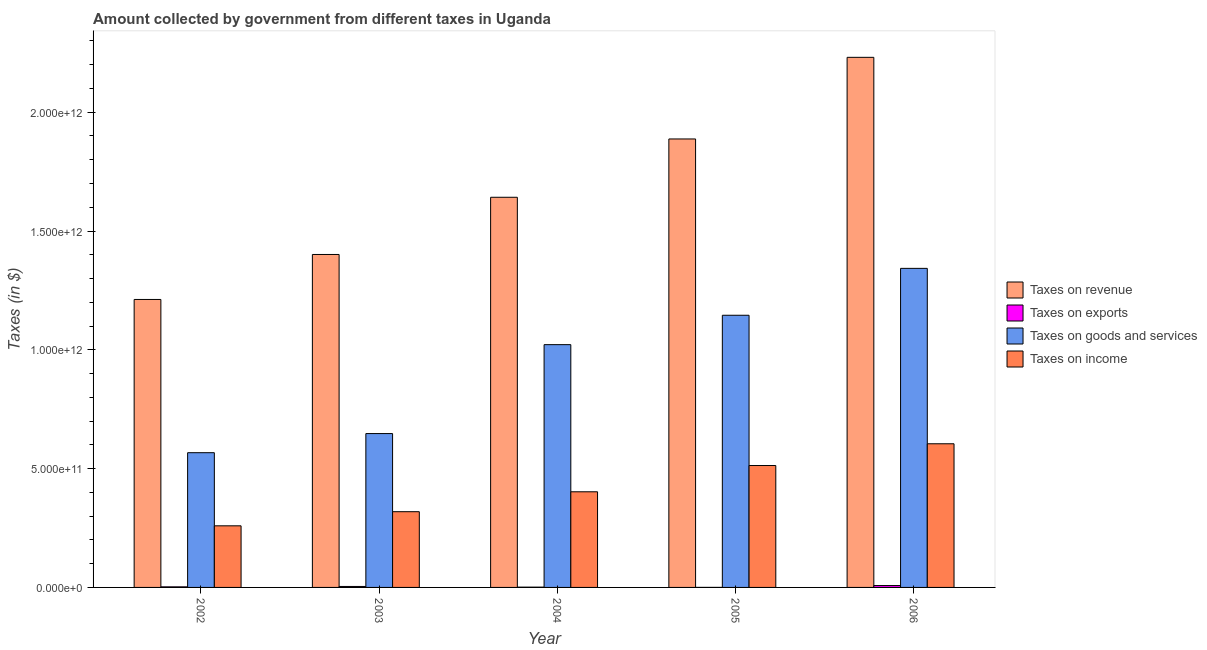How many different coloured bars are there?
Provide a short and direct response. 4. Are the number of bars on each tick of the X-axis equal?
Provide a succinct answer. Yes. How many bars are there on the 3rd tick from the right?
Your answer should be compact. 4. What is the label of the 4th group of bars from the left?
Keep it short and to the point. 2005. What is the amount collected as tax on revenue in 2006?
Ensure brevity in your answer.  2.23e+12. Across all years, what is the maximum amount collected as tax on income?
Make the answer very short. 6.05e+11. Across all years, what is the minimum amount collected as tax on income?
Ensure brevity in your answer.  2.59e+11. In which year was the amount collected as tax on income maximum?
Give a very brief answer. 2006. What is the total amount collected as tax on income in the graph?
Provide a short and direct response. 2.10e+12. What is the difference between the amount collected as tax on revenue in 2005 and that in 2006?
Your answer should be compact. -3.44e+11. What is the difference between the amount collected as tax on income in 2004 and the amount collected as tax on goods in 2002?
Your answer should be compact. 1.43e+11. What is the average amount collected as tax on goods per year?
Make the answer very short. 9.45e+11. In the year 2003, what is the difference between the amount collected as tax on goods and amount collected as tax on exports?
Your answer should be compact. 0. What is the ratio of the amount collected as tax on revenue in 2003 to that in 2004?
Keep it short and to the point. 0.85. What is the difference between the highest and the second highest amount collected as tax on revenue?
Keep it short and to the point. 3.44e+11. What is the difference between the highest and the lowest amount collected as tax on income?
Provide a short and direct response. 3.45e+11. In how many years, is the amount collected as tax on goods greater than the average amount collected as tax on goods taken over all years?
Offer a very short reply. 3. What does the 1st bar from the left in 2002 represents?
Make the answer very short. Taxes on revenue. What does the 3rd bar from the right in 2004 represents?
Your response must be concise. Taxes on exports. How many bars are there?
Your answer should be compact. 20. Are all the bars in the graph horizontal?
Your answer should be very brief. No. How many years are there in the graph?
Keep it short and to the point. 5. What is the difference between two consecutive major ticks on the Y-axis?
Keep it short and to the point. 5.00e+11. Are the values on the major ticks of Y-axis written in scientific E-notation?
Provide a short and direct response. Yes. Does the graph contain any zero values?
Offer a very short reply. No. How many legend labels are there?
Keep it short and to the point. 4. How are the legend labels stacked?
Provide a short and direct response. Vertical. What is the title of the graph?
Provide a succinct answer. Amount collected by government from different taxes in Uganda. Does "Australia" appear as one of the legend labels in the graph?
Your response must be concise. No. What is the label or title of the Y-axis?
Provide a succinct answer. Taxes (in $). What is the Taxes (in $) in Taxes on revenue in 2002?
Provide a succinct answer. 1.21e+12. What is the Taxes (in $) in Taxes on exports in 2002?
Provide a short and direct response. 2.43e+09. What is the Taxes (in $) in Taxes on goods and services in 2002?
Keep it short and to the point. 5.67e+11. What is the Taxes (in $) of Taxes on income in 2002?
Keep it short and to the point. 2.59e+11. What is the Taxes (in $) of Taxes on revenue in 2003?
Make the answer very short. 1.40e+12. What is the Taxes (in $) of Taxes on exports in 2003?
Provide a succinct answer. 4.07e+09. What is the Taxes (in $) in Taxes on goods and services in 2003?
Make the answer very short. 6.48e+11. What is the Taxes (in $) in Taxes on income in 2003?
Keep it short and to the point. 3.19e+11. What is the Taxes (in $) of Taxes on revenue in 2004?
Your response must be concise. 1.64e+12. What is the Taxes (in $) in Taxes on exports in 2004?
Provide a succinct answer. 1.14e+09. What is the Taxes (in $) of Taxes on goods and services in 2004?
Provide a short and direct response. 1.02e+12. What is the Taxes (in $) of Taxes on income in 2004?
Ensure brevity in your answer.  4.02e+11. What is the Taxes (in $) of Taxes on revenue in 2005?
Offer a terse response. 1.89e+12. What is the Taxes (in $) of Taxes on exports in 2005?
Your response must be concise. 1.22e+08. What is the Taxes (in $) of Taxes on goods and services in 2005?
Give a very brief answer. 1.15e+12. What is the Taxes (in $) of Taxes on income in 2005?
Offer a very short reply. 5.13e+11. What is the Taxes (in $) of Taxes on revenue in 2006?
Offer a terse response. 2.23e+12. What is the Taxes (in $) in Taxes on exports in 2006?
Give a very brief answer. 7.93e+09. What is the Taxes (in $) in Taxes on goods and services in 2006?
Provide a short and direct response. 1.34e+12. What is the Taxes (in $) of Taxes on income in 2006?
Ensure brevity in your answer.  6.05e+11. Across all years, what is the maximum Taxes (in $) of Taxes on revenue?
Your answer should be compact. 2.23e+12. Across all years, what is the maximum Taxes (in $) of Taxes on exports?
Offer a very short reply. 7.93e+09. Across all years, what is the maximum Taxes (in $) of Taxes on goods and services?
Give a very brief answer. 1.34e+12. Across all years, what is the maximum Taxes (in $) in Taxes on income?
Your response must be concise. 6.05e+11. Across all years, what is the minimum Taxes (in $) in Taxes on revenue?
Offer a very short reply. 1.21e+12. Across all years, what is the minimum Taxes (in $) of Taxes on exports?
Your response must be concise. 1.22e+08. Across all years, what is the minimum Taxes (in $) of Taxes on goods and services?
Your response must be concise. 5.67e+11. Across all years, what is the minimum Taxes (in $) of Taxes on income?
Keep it short and to the point. 2.59e+11. What is the total Taxes (in $) in Taxes on revenue in the graph?
Your response must be concise. 8.37e+12. What is the total Taxes (in $) of Taxes on exports in the graph?
Give a very brief answer. 1.57e+1. What is the total Taxes (in $) of Taxes on goods and services in the graph?
Keep it short and to the point. 4.72e+12. What is the total Taxes (in $) of Taxes on income in the graph?
Provide a succinct answer. 2.10e+12. What is the difference between the Taxes (in $) of Taxes on revenue in 2002 and that in 2003?
Your answer should be very brief. -1.89e+11. What is the difference between the Taxes (in $) of Taxes on exports in 2002 and that in 2003?
Your answer should be very brief. -1.64e+09. What is the difference between the Taxes (in $) of Taxes on goods and services in 2002 and that in 2003?
Offer a terse response. -8.05e+1. What is the difference between the Taxes (in $) of Taxes on income in 2002 and that in 2003?
Keep it short and to the point. -5.94e+1. What is the difference between the Taxes (in $) in Taxes on revenue in 2002 and that in 2004?
Offer a very short reply. -4.30e+11. What is the difference between the Taxes (in $) of Taxes on exports in 2002 and that in 2004?
Provide a short and direct response. 1.30e+09. What is the difference between the Taxes (in $) of Taxes on goods and services in 2002 and that in 2004?
Give a very brief answer. -4.55e+11. What is the difference between the Taxes (in $) of Taxes on income in 2002 and that in 2004?
Offer a very short reply. -1.43e+11. What is the difference between the Taxes (in $) of Taxes on revenue in 2002 and that in 2005?
Ensure brevity in your answer.  -6.75e+11. What is the difference between the Taxes (in $) of Taxes on exports in 2002 and that in 2005?
Make the answer very short. 2.31e+09. What is the difference between the Taxes (in $) in Taxes on goods and services in 2002 and that in 2005?
Your answer should be compact. -5.78e+11. What is the difference between the Taxes (in $) in Taxes on income in 2002 and that in 2005?
Ensure brevity in your answer.  -2.54e+11. What is the difference between the Taxes (in $) of Taxes on revenue in 2002 and that in 2006?
Your answer should be very brief. -1.02e+12. What is the difference between the Taxes (in $) of Taxes on exports in 2002 and that in 2006?
Offer a terse response. -5.50e+09. What is the difference between the Taxes (in $) of Taxes on goods and services in 2002 and that in 2006?
Your response must be concise. -7.76e+11. What is the difference between the Taxes (in $) in Taxes on income in 2002 and that in 2006?
Provide a succinct answer. -3.45e+11. What is the difference between the Taxes (in $) in Taxes on revenue in 2003 and that in 2004?
Offer a very short reply. -2.41e+11. What is the difference between the Taxes (in $) of Taxes on exports in 2003 and that in 2004?
Give a very brief answer. 2.94e+09. What is the difference between the Taxes (in $) in Taxes on goods and services in 2003 and that in 2004?
Give a very brief answer. -3.74e+11. What is the difference between the Taxes (in $) in Taxes on income in 2003 and that in 2004?
Offer a terse response. -8.38e+1. What is the difference between the Taxes (in $) in Taxes on revenue in 2003 and that in 2005?
Give a very brief answer. -4.86e+11. What is the difference between the Taxes (in $) in Taxes on exports in 2003 and that in 2005?
Provide a succinct answer. 3.95e+09. What is the difference between the Taxes (in $) in Taxes on goods and services in 2003 and that in 2005?
Give a very brief answer. -4.98e+11. What is the difference between the Taxes (in $) in Taxes on income in 2003 and that in 2005?
Your response must be concise. -1.94e+11. What is the difference between the Taxes (in $) of Taxes on revenue in 2003 and that in 2006?
Provide a short and direct response. -8.30e+11. What is the difference between the Taxes (in $) of Taxes on exports in 2003 and that in 2006?
Make the answer very short. -3.86e+09. What is the difference between the Taxes (in $) in Taxes on goods and services in 2003 and that in 2006?
Give a very brief answer. -6.95e+11. What is the difference between the Taxes (in $) in Taxes on income in 2003 and that in 2006?
Ensure brevity in your answer.  -2.86e+11. What is the difference between the Taxes (in $) of Taxes on revenue in 2004 and that in 2005?
Keep it short and to the point. -2.45e+11. What is the difference between the Taxes (in $) in Taxes on exports in 2004 and that in 2005?
Your answer should be very brief. 1.01e+09. What is the difference between the Taxes (in $) in Taxes on goods and services in 2004 and that in 2005?
Offer a terse response. -1.24e+11. What is the difference between the Taxes (in $) in Taxes on income in 2004 and that in 2005?
Your answer should be compact. -1.11e+11. What is the difference between the Taxes (in $) of Taxes on revenue in 2004 and that in 2006?
Provide a short and direct response. -5.89e+11. What is the difference between the Taxes (in $) in Taxes on exports in 2004 and that in 2006?
Make the answer very short. -6.79e+09. What is the difference between the Taxes (in $) of Taxes on goods and services in 2004 and that in 2006?
Your answer should be very brief. -3.21e+11. What is the difference between the Taxes (in $) in Taxes on income in 2004 and that in 2006?
Your answer should be very brief. -2.02e+11. What is the difference between the Taxes (in $) in Taxes on revenue in 2005 and that in 2006?
Give a very brief answer. -3.44e+11. What is the difference between the Taxes (in $) of Taxes on exports in 2005 and that in 2006?
Offer a very short reply. -7.81e+09. What is the difference between the Taxes (in $) of Taxes on goods and services in 2005 and that in 2006?
Offer a very short reply. -1.97e+11. What is the difference between the Taxes (in $) of Taxes on income in 2005 and that in 2006?
Provide a succinct answer. -9.16e+1. What is the difference between the Taxes (in $) of Taxes on revenue in 2002 and the Taxes (in $) of Taxes on exports in 2003?
Offer a terse response. 1.21e+12. What is the difference between the Taxes (in $) of Taxes on revenue in 2002 and the Taxes (in $) of Taxes on goods and services in 2003?
Keep it short and to the point. 5.64e+11. What is the difference between the Taxes (in $) in Taxes on revenue in 2002 and the Taxes (in $) in Taxes on income in 2003?
Offer a terse response. 8.93e+11. What is the difference between the Taxes (in $) in Taxes on exports in 2002 and the Taxes (in $) in Taxes on goods and services in 2003?
Ensure brevity in your answer.  -6.45e+11. What is the difference between the Taxes (in $) in Taxes on exports in 2002 and the Taxes (in $) in Taxes on income in 2003?
Offer a terse response. -3.16e+11. What is the difference between the Taxes (in $) in Taxes on goods and services in 2002 and the Taxes (in $) in Taxes on income in 2003?
Provide a short and direct response. 2.48e+11. What is the difference between the Taxes (in $) in Taxes on revenue in 2002 and the Taxes (in $) in Taxes on exports in 2004?
Ensure brevity in your answer.  1.21e+12. What is the difference between the Taxes (in $) in Taxes on revenue in 2002 and the Taxes (in $) in Taxes on goods and services in 2004?
Make the answer very short. 1.90e+11. What is the difference between the Taxes (in $) of Taxes on revenue in 2002 and the Taxes (in $) of Taxes on income in 2004?
Make the answer very short. 8.09e+11. What is the difference between the Taxes (in $) of Taxes on exports in 2002 and the Taxes (in $) of Taxes on goods and services in 2004?
Keep it short and to the point. -1.02e+12. What is the difference between the Taxes (in $) of Taxes on exports in 2002 and the Taxes (in $) of Taxes on income in 2004?
Make the answer very short. -4.00e+11. What is the difference between the Taxes (in $) of Taxes on goods and services in 2002 and the Taxes (in $) of Taxes on income in 2004?
Keep it short and to the point. 1.65e+11. What is the difference between the Taxes (in $) in Taxes on revenue in 2002 and the Taxes (in $) in Taxes on exports in 2005?
Give a very brief answer. 1.21e+12. What is the difference between the Taxes (in $) of Taxes on revenue in 2002 and the Taxes (in $) of Taxes on goods and services in 2005?
Your response must be concise. 6.65e+1. What is the difference between the Taxes (in $) of Taxes on revenue in 2002 and the Taxes (in $) of Taxes on income in 2005?
Keep it short and to the point. 6.99e+11. What is the difference between the Taxes (in $) in Taxes on exports in 2002 and the Taxes (in $) in Taxes on goods and services in 2005?
Keep it short and to the point. -1.14e+12. What is the difference between the Taxes (in $) of Taxes on exports in 2002 and the Taxes (in $) of Taxes on income in 2005?
Your answer should be compact. -5.11e+11. What is the difference between the Taxes (in $) of Taxes on goods and services in 2002 and the Taxes (in $) of Taxes on income in 2005?
Your response must be concise. 5.40e+1. What is the difference between the Taxes (in $) of Taxes on revenue in 2002 and the Taxes (in $) of Taxes on exports in 2006?
Offer a very short reply. 1.20e+12. What is the difference between the Taxes (in $) in Taxes on revenue in 2002 and the Taxes (in $) in Taxes on goods and services in 2006?
Your answer should be compact. -1.31e+11. What is the difference between the Taxes (in $) in Taxes on revenue in 2002 and the Taxes (in $) in Taxes on income in 2006?
Your response must be concise. 6.07e+11. What is the difference between the Taxes (in $) in Taxes on exports in 2002 and the Taxes (in $) in Taxes on goods and services in 2006?
Make the answer very short. -1.34e+12. What is the difference between the Taxes (in $) of Taxes on exports in 2002 and the Taxes (in $) of Taxes on income in 2006?
Offer a very short reply. -6.02e+11. What is the difference between the Taxes (in $) of Taxes on goods and services in 2002 and the Taxes (in $) of Taxes on income in 2006?
Offer a very short reply. -3.76e+1. What is the difference between the Taxes (in $) of Taxes on revenue in 2003 and the Taxes (in $) of Taxes on exports in 2004?
Your answer should be compact. 1.40e+12. What is the difference between the Taxes (in $) in Taxes on revenue in 2003 and the Taxes (in $) in Taxes on goods and services in 2004?
Provide a short and direct response. 3.80e+11. What is the difference between the Taxes (in $) of Taxes on revenue in 2003 and the Taxes (in $) of Taxes on income in 2004?
Offer a terse response. 9.99e+11. What is the difference between the Taxes (in $) in Taxes on exports in 2003 and the Taxes (in $) in Taxes on goods and services in 2004?
Your response must be concise. -1.02e+12. What is the difference between the Taxes (in $) in Taxes on exports in 2003 and the Taxes (in $) in Taxes on income in 2004?
Give a very brief answer. -3.98e+11. What is the difference between the Taxes (in $) in Taxes on goods and services in 2003 and the Taxes (in $) in Taxes on income in 2004?
Make the answer very short. 2.45e+11. What is the difference between the Taxes (in $) in Taxes on revenue in 2003 and the Taxes (in $) in Taxes on exports in 2005?
Offer a very short reply. 1.40e+12. What is the difference between the Taxes (in $) of Taxes on revenue in 2003 and the Taxes (in $) of Taxes on goods and services in 2005?
Give a very brief answer. 2.56e+11. What is the difference between the Taxes (in $) in Taxes on revenue in 2003 and the Taxes (in $) in Taxes on income in 2005?
Keep it short and to the point. 8.88e+11. What is the difference between the Taxes (in $) in Taxes on exports in 2003 and the Taxes (in $) in Taxes on goods and services in 2005?
Offer a terse response. -1.14e+12. What is the difference between the Taxes (in $) of Taxes on exports in 2003 and the Taxes (in $) of Taxes on income in 2005?
Provide a short and direct response. -5.09e+11. What is the difference between the Taxes (in $) of Taxes on goods and services in 2003 and the Taxes (in $) of Taxes on income in 2005?
Ensure brevity in your answer.  1.34e+11. What is the difference between the Taxes (in $) of Taxes on revenue in 2003 and the Taxes (in $) of Taxes on exports in 2006?
Your answer should be very brief. 1.39e+12. What is the difference between the Taxes (in $) of Taxes on revenue in 2003 and the Taxes (in $) of Taxes on goods and services in 2006?
Offer a terse response. 5.84e+1. What is the difference between the Taxes (in $) of Taxes on revenue in 2003 and the Taxes (in $) of Taxes on income in 2006?
Your answer should be compact. 7.97e+11. What is the difference between the Taxes (in $) of Taxes on exports in 2003 and the Taxes (in $) of Taxes on goods and services in 2006?
Provide a succinct answer. -1.34e+12. What is the difference between the Taxes (in $) in Taxes on exports in 2003 and the Taxes (in $) in Taxes on income in 2006?
Give a very brief answer. -6.01e+11. What is the difference between the Taxes (in $) of Taxes on goods and services in 2003 and the Taxes (in $) of Taxes on income in 2006?
Provide a succinct answer. 4.29e+1. What is the difference between the Taxes (in $) in Taxes on revenue in 2004 and the Taxes (in $) in Taxes on exports in 2005?
Provide a short and direct response. 1.64e+12. What is the difference between the Taxes (in $) of Taxes on revenue in 2004 and the Taxes (in $) of Taxes on goods and services in 2005?
Offer a terse response. 4.97e+11. What is the difference between the Taxes (in $) of Taxes on revenue in 2004 and the Taxes (in $) of Taxes on income in 2005?
Your answer should be very brief. 1.13e+12. What is the difference between the Taxes (in $) in Taxes on exports in 2004 and the Taxes (in $) in Taxes on goods and services in 2005?
Give a very brief answer. -1.14e+12. What is the difference between the Taxes (in $) of Taxes on exports in 2004 and the Taxes (in $) of Taxes on income in 2005?
Ensure brevity in your answer.  -5.12e+11. What is the difference between the Taxes (in $) of Taxes on goods and services in 2004 and the Taxes (in $) of Taxes on income in 2005?
Offer a terse response. 5.09e+11. What is the difference between the Taxes (in $) of Taxes on revenue in 2004 and the Taxes (in $) of Taxes on exports in 2006?
Make the answer very short. 1.63e+12. What is the difference between the Taxes (in $) in Taxes on revenue in 2004 and the Taxes (in $) in Taxes on goods and services in 2006?
Your response must be concise. 2.99e+11. What is the difference between the Taxes (in $) in Taxes on revenue in 2004 and the Taxes (in $) in Taxes on income in 2006?
Your response must be concise. 1.04e+12. What is the difference between the Taxes (in $) of Taxes on exports in 2004 and the Taxes (in $) of Taxes on goods and services in 2006?
Keep it short and to the point. -1.34e+12. What is the difference between the Taxes (in $) in Taxes on exports in 2004 and the Taxes (in $) in Taxes on income in 2006?
Ensure brevity in your answer.  -6.03e+11. What is the difference between the Taxes (in $) of Taxes on goods and services in 2004 and the Taxes (in $) of Taxes on income in 2006?
Make the answer very short. 4.17e+11. What is the difference between the Taxes (in $) of Taxes on revenue in 2005 and the Taxes (in $) of Taxes on exports in 2006?
Your response must be concise. 1.88e+12. What is the difference between the Taxes (in $) in Taxes on revenue in 2005 and the Taxes (in $) in Taxes on goods and services in 2006?
Keep it short and to the point. 5.45e+11. What is the difference between the Taxes (in $) of Taxes on revenue in 2005 and the Taxes (in $) of Taxes on income in 2006?
Make the answer very short. 1.28e+12. What is the difference between the Taxes (in $) in Taxes on exports in 2005 and the Taxes (in $) in Taxes on goods and services in 2006?
Provide a succinct answer. -1.34e+12. What is the difference between the Taxes (in $) of Taxes on exports in 2005 and the Taxes (in $) of Taxes on income in 2006?
Offer a terse response. -6.04e+11. What is the difference between the Taxes (in $) of Taxes on goods and services in 2005 and the Taxes (in $) of Taxes on income in 2006?
Your answer should be compact. 5.41e+11. What is the average Taxes (in $) in Taxes on revenue per year?
Give a very brief answer. 1.67e+12. What is the average Taxes (in $) in Taxes on exports per year?
Offer a very short reply. 3.14e+09. What is the average Taxes (in $) of Taxes on goods and services per year?
Your response must be concise. 9.45e+11. What is the average Taxes (in $) of Taxes on income per year?
Offer a very short reply. 4.20e+11. In the year 2002, what is the difference between the Taxes (in $) of Taxes on revenue and Taxes (in $) of Taxes on exports?
Keep it short and to the point. 1.21e+12. In the year 2002, what is the difference between the Taxes (in $) of Taxes on revenue and Taxes (in $) of Taxes on goods and services?
Offer a very short reply. 6.45e+11. In the year 2002, what is the difference between the Taxes (in $) in Taxes on revenue and Taxes (in $) in Taxes on income?
Keep it short and to the point. 9.53e+11. In the year 2002, what is the difference between the Taxes (in $) of Taxes on exports and Taxes (in $) of Taxes on goods and services?
Make the answer very short. -5.65e+11. In the year 2002, what is the difference between the Taxes (in $) in Taxes on exports and Taxes (in $) in Taxes on income?
Make the answer very short. -2.57e+11. In the year 2002, what is the difference between the Taxes (in $) in Taxes on goods and services and Taxes (in $) in Taxes on income?
Your answer should be very brief. 3.08e+11. In the year 2003, what is the difference between the Taxes (in $) of Taxes on revenue and Taxes (in $) of Taxes on exports?
Your answer should be compact. 1.40e+12. In the year 2003, what is the difference between the Taxes (in $) in Taxes on revenue and Taxes (in $) in Taxes on goods and services?
Offer a very short reply. 7.54e+11. In the year 2003, what is the difference between the Taxes (in $) of Taxes on revenue and Taxes (in $) of Taxes on income?
Your response must be concise. 1.08e+12. In the year 2003, what is the difference between the Taxes (in $) in Taxes on exports and Taxes (in $) in Taxes on goods and services?
Offer a terse response. -6.43e+11. In the year 2003, what is the difference between the Taxes (in $) of Taxes on exports and Taxes (in $) of Taxes on income?
Your answer should be very brief. -3.15e+11. In the year 2003, what is the difference between the Taxes (in $) in Taxes on goods and services and Taxes (in $) in Taxes on income?
Keep it short and to the point. 3.29e+11. In the year 2004, what is the difference between the Taxes (in $) of Taxes on revenue and Taxes (in $) of Taxes on exports?
Your response must be concise. 1.64e+12. In the year 2004, what is the difference between the Taxes (in $) of Taxes on revenue and Taxes (in $) of Taxes on goods and services?
Your answer should be compact. 6.20e+11. In the year 2004, what is the difference between the Taxes (in $) in Taxes on revenue and Taxes (in $) in Taxes on income?
Your answer should be very brief. 1.24e+12. In the year 2004, what is the difference between the Taxes (in $) in Taxes on exports and Taxes (in $) in Taxes on goods and services?
Your response must be concise. -1.02e+12. In the year 2004, what is the difference between the Taxes (in $) in Taxes on exports and Taxes (in $) in Taxes on income?
Ensure brevity in your answer.  -4.01e+11. In the year 2004, what is the difference between the Taxes (in $) in Taxes on goods and services and Taxes (in $) in Taxes on income?
Provide a succinct answer. 6.19e+11. In the year 2005, what is the difference between the Taxes (in $) in Taxes on revenue and Taxes (in $) in Taxes on exports?
Provide a short and direct response. 1.89e+12. In the year 2005, what is the difference between the Taxes (in $) in Taxes on revenue and Taxes (in $) in Taxes on goods and services?
Your answer should be compact. 7.42e+11. In the year 2005, what is the difference between the Taxes (in $) of Taxes on revenue and Taxes (in $) of Taxes on income?
Your response must be concise. 1.37e+12. In the year 2005, what is the difference between the Taxes (in $) in Taxes on exports and Taxes (in $) in Taxes on goods and services?
Offer a very short reply. -1.15e+12. In the year 2005, what is the difference between the Taxes (in $) of Taxes on exports and Taxes (in $) of Taxes on income?
Provide a short and direct response. -5.13e+11. In the year 2005, what is the difference between the Taxes (in $) of Taxes on goods and services and Taxes (in $) of Taxes on income?
Provide a succinct answer. 6.32e+11. In the year 2006, what is the difference between the Taxes (in $) in Taxes on revenue and Taxes (in $) in Taxes on exports?
Make the answer very short. 2.22e+12. In the year 2006, what is the difference between the Taxes (in $) in Taxes on revenue and Taxes (in $) in Taxes on goods and services?
Keep it short and to the point. 8.88e+11. In the year 2006, what is the difference between the Taxes (in $) in Taxes on revenue and Taxes (in $) in Taxes on income?
Ensure brevity in your answer.  1.63e+12. In the year 2006, what is the difference between the Taxes (in $) in Taxes on exports and Taxes (in $) in Taxes on goods and services?
Your answer should be compact. -1.33e+12. In the year 2006, what is the difference between the Taxes (in $) in Taxes on exports and Taxes (in $) in Taxes on income?
Your response must be concise. -5.97e+11. In the year 2006, what is the difference between the Taxes (in $) in Taxes on goods and services and Taxes (in $) in Taxes on income?
Offer a terse response. 7.38e+11. What is the ratio of the Taxes (in $) of Taxes on revenue in 2002 to that in 2003?
Provide a short and direct response. 0.86. What is the ratio of the Taxes (in $) in Taxes on exports in 2002 to that in 2003?
Offer a very short reply. 0.6. What is the ratio of the Taxes (in $) of Taxes on goods and services in 2002 to that in 2003?
Your answer should be compact. 0.88. What is the ratio of the Taxes (in $) in Taxes on income in 2002 to that in 2003?
Your answer should be compact. 0.81. What is the ratio of the Taxes (in $) of Taxes on revenue in 2002 to that in 2004?
Offer a terse response. 0.74. What is the ratio of the Taxes (in $) in Taxes on exports in 2002 to that in 2004?
Make the answer very short. 2.14. What is the ratio of the Taxes (in $) of Taxes on goods and services in 2002 to that in 2004?
Offer a very short reply. 0.55. What is the ratio of the Taxes (in $) of Taxes on income in 2002 to that in 2004?
Provide a short and direct response. 0.64. What is the ratio of the Taxes (in $) of Taxes on revenue in 2002 to that in 2005?
Make the answer very short. 0.64. What is the ratio of the Taxes (in $) in Taxes on exports in 2002 to that in 2005?
Offer a very short reply. 19.97. What is the ratio of the Taxes (in $) in Taxes on goods and services in 2002 to that in 2005?
Your response must be concise. 0.49. What is the ratio of the Taxes (in $) of Taxes on income in 2002 to that in 2005?
Give a very brief answer. 0.51. What is the ratio of the Taxes (in $) in Taxes on revenue in 2002 to that in 2006?
Provide a short and direct response. 0.54. What is the ratio of the Taxes (in $) of Taxes on exports in 2002 to that in 2006?
Give a very brief answer. 0.31. What is the ratio of the Taxes (in $) in Taxes on goods and services in 2002 to that in 2006?
Keep it short and to the point. 0.42. What is the ratio of the Taxes (in $) in Taxes on income in 2002 to that in 2006?
Your answer should be compact. 0.43. What is the ratio of the Taxes (in $) in Taxes on revenue in 2003 to that in 2004?
Offer a very short reply. 0.85. What is the ratio of the Taxes (in $) in Taxes on exports in 2003 to that in 2004?
Keep it short and to the point. 3.58. What is the ratio of the Taxes (in $) in Taxes on goods and services in 2003 to that in 2004?
Offer a terse response. 0.63. What is the ratio of the Taxes (in $) in Taxes on income in 2003 to that in 2004?
Offer a very short reply. 0.79. What is the ratio of the Taxes (in $) of Taxes on revenue in 2003 to that in 2005?
Your answer should be very brief. 0.74. What is the ratio of the Taxes (in $) of Taxes on exports in 2003 to that in 2005?
Provide a short and direct response. 33.44. What is the ratio of the Taxes (in $) in Taxes on goods and services in 2003 to that in 2005?
Your response must be concise. 0.57. What is the ratio of the Taxes (in $) of Taxes on income in 2003 to that in 2005?
Your response must be concise. 0.62. What is the ratio of the Taxes (in $) in Taxes on revenue in 2003 to that in 2006?
Keep it short and to the point. 0.63. What is the ratio of the Taxes (in $) of Taxes on exports in 2003 to that in 2006?
Give a very brief answer. 0.51. What is the ratio of the Taxes (in $) of Taxes on goods and services in 2003 to that in 2006?
Keep it short and to the point. 0.48. What is the ratio of the Taxes (in $) of Taxes on income in 2003 to that in 2006?
Provide a succinct answer. 0.53. What is the ratio of the Taxes (in $) in Taxes on revenue in 2004 to that in 2005?
Keep it short and to the point. 0.87. What is the ratio of the Taxes (in $) of Taxes on exports in 2004 to that in 2005?
Give a very brief answer. 9.33. What is the ratio of the Taxes (in $) of Taxes on goods and services in 2004 to that in 2005?
Make the answer very short. 0.89. What is the ratio of the Taxes (in $) of Taxes on income in 2004 to that in 2005?
Offer a terse response. 0.78. What is the ratio of the Taxes (in $) in Taxes on revenue in 2004 to that in 2006?
Keep it short and to the point. 0.74. What is the ratio of the Taxes (in $) in Taxes on exports in 2004 to that in 2006?
Provide a short and direct response. 0.14. What is the ratio of the Taxes (in $) in Taxes on goods and services in 2004 to that in 2006?
Your answer should be very brief. 0.76. What is the ratio of the Taxes (in $) of Taxes on income in 2004 to that in 2006?
Keep it short and to the point. 0.67. What is the ratio of the Taxes (in $) of Taxes on revenue in 2005 to that in 2006?
Provide a succinct answer. 0.85. What is the ratio of the Taxes (in $) in Taxes on exports in 2005 to that in 2006?
Provide a short and direct response. 0.02. What is the ratio of the Taxes (in $) of Taxes on goods and services in 2005 to that in 2006?
Your response must be concise. 0.85. What is the ratio of the Taxes (in $) of Taxes on income in 2005 to that in 2006?
Give a very brief answer. 0.85. What is the difference between the highest and the second highest Taxes (in $) in Taxes on revenue?
Your answer should be compact. 3.44e+11. What is the difference between the highest and the second highest Taxes (in $) in Taxes on exports?
Give a very brief answer. 3.86e+09. What is the difference between the highest and the second highest Taxes (in $) in Taxes on goods and services?
Provide a short and direct response. 1.97e+11. What is the difference between the highest and the second highest Taxes (in $) in Taxes on income?
Your response must be concise. 9.16e+1. What is the difference between the highest and the lowest Taxes (in $) in Taxes on revenue?
Make the answer very short. 1.02e+12. What is the difference between the highest and the lowest Taxes (in $) of Taxes on exports?
Your response must be concise. 7.81e+09. What is the difference between the highest and the lowest Taxes (in $) in Taxes on goods and services?
Offer a very short reply. 7.76e+11. What is the difference between the highest and the lowest Taxes (in $) in Taxes on income?
Your response must be concise. 3.45e+11. 